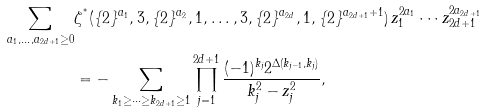<formula> <loc_0><loc_0><loc_500><loc_500>\sum _ { a _ { 1 } , \dots , a _ { 2 d + 1 } \geq 0 } & \zeta ^ { ^ { * } } ( \{ 2 \} ^ { a _ { 1 } } , 3 , \{ 2 \} ^ { a _ { 2 } } , 1 , \dots , 3 , \{ 2 \} ^ { a _ { 2 d } } , 1 , \{ 2 \} ^ { a _ { 2 d + 1 } + 1 } ) \, z _ { 1 } ^ { 2 a _ { 1 } } \cdots z _ { 2 d + 1 } ^ { 2 a _ { 2 d + 1 } } \\ & = - \sum _ { k _ { 1 } \geq \cdots \geq k _ { 2 d + 1 } \geq 1 } \prod _ { j = 1 } ^ { 2 d + 1 } \frac { ( - 1 ) ^ { k _ { j } } 2 ^ { \Delta ( k _ { j - 1 } , k _ { j } ) } } { k _ { j } ^ { 2 } - z _ { j } ^ { 2 } } ,</formula> 